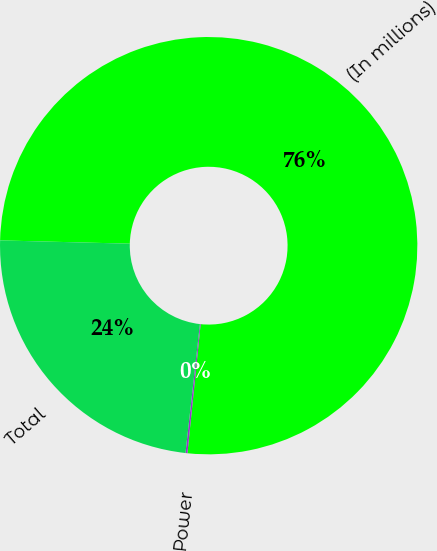Convert chart to OTSL. <chart><loc_0><loc_0><loc_500><loc_500><pie_chart><fcel>(In millions)<fcel>Power<fcel>Total<nl><fcel>76.22%<fcel>0.15%<fcel>23.63%<nl></chart> 